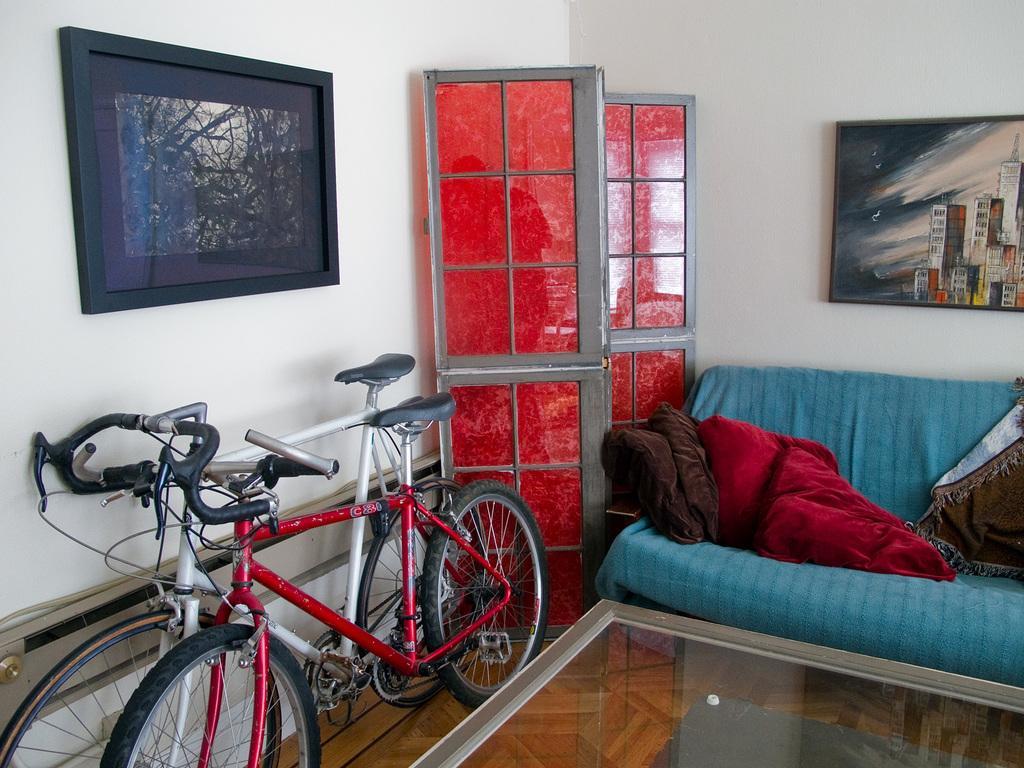How would you summarize this image in a sentence or two? This image is clicked inside the room where there is a sofa on the right side and two bicycles on the left side. There is a photo frame on the left side to the wall ,there are two doors placed in the middle of the image and there is also a wall painting on the right side. There is a table in the bottom ,the cycles which are placed on the left side one of them is red and the other one is white. 